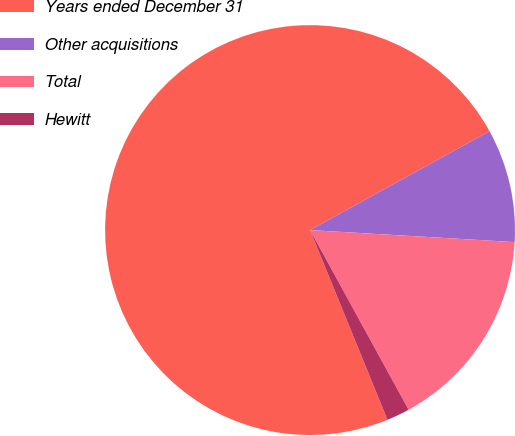Convert chart to OTSL. <chart><loc_0><loc_0><loc_500><loc_500><pie_chart><fcel>Years ended December 31<fcel>Other acquisitions<fcel>Total<fcel>Hewitt<nl><fcel>73.15%<fcel>8.95%<fcel>16.08%<fcel>1.82%<nl></chart> 